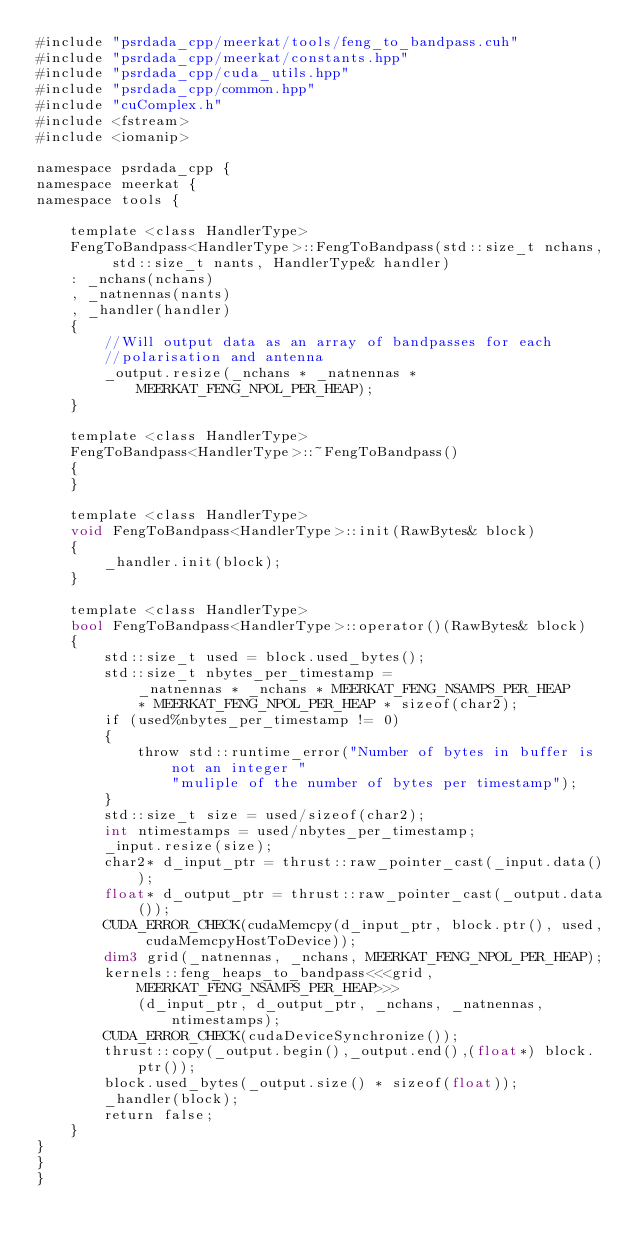<code> <loc_0><loc_0><loc_500><loc_500><_Cuda_>#include "psrdada_cpp/meerkat/tools/feng_to_bandpass.cuh"
#include "psrdada_cpp/meerkat/constants.hpp"
#include "psrdada_cpp/cuda_utils.hpp"
#include "psrdada_cpp/common.hpp"
#include "cuComplex.h"
#include <fstream>
#include <iomanip>

namespace psrdada_cpp {
namespace meerkat {
namespace tools {

    template <class HandlerType>
    FengToBandpass<HandlerType>::FengToBandpass(std::size_t nchans, std::size_t nants, HandlerType& handler)
    : _nchans(nchans)
    , _natnennas(nants)
    , _handler(handler)
    {
        //Will output data as an array of bandpasses for each
        //polarisation and antenna
        _output.resize(_nchans * _natnennas * MEERKAT_FENG_NPOL_PER_HEAP);
    }

    template <class HandlerType>
    FengToBandpass<HandlerType>::~FengToBandpass()
    {
    }

    template <class HandlerType>
    void FengToBandpass<HandlerType>::init(RawBytes& block)
    {
        _handler.init(block);
    }

    template <class HandlerType>
    bool FengToBandpass<HandlerType>::operator()(RawBytes& block)
    {
        std::size_t used = block.used_bytes();
        std::size_t nbytes_per_timestamp =
            _natnennas * _nchans * MEERKAT_FENG_NSAMPS_PER_HEAP
            * MEERKAT_FENG_NPOL_PER_HEAP * sizeof(char2);
        if (used%nbytes_per_timestamp != 0)
        {
            throw std::runtime_error("Number of bytes in buffer is not an integer "
                "muliple of the number of bytes per timestamp");
        }
        std::size_t size = used/sizeof(char2);
        int ntimestamps = used/nbytes_per_timestamp;
        _input.resize(size);
        char2* d_input_ptr = thrust::raw_pointer_cast(_input.data());
        float* d_output_ptr = thrust::raw_pointer_cast(_output.data());
        CUDA_ERROR_CHECK(cudaMemcpy(d_input_ptr, block.ptr(), used, cudaMemcpyHostToDevice));
        dim3 grid(_natnennas, _nchans, MEERKAT_FENG_NPOL_PER_HEAP);
        kernels::feng_heaps_to_bandpass<<<grid, MEERKAT_FENG_NSAMPS_PER_HEAP>>>
            (d_input_ptr, d_output_ptr, _nchans, _natnennas, ntimestamps);
        CUDA_ERROR_CHECK(cudaDeviceSynchronize());
        thrust::copy(_output.begin(),_output.end(),(float*) block.ptr());
        block.used_bytes(_output.size() * sizeof(float));
        _handler(block);
        return false;
    }
}
}
}</code> 